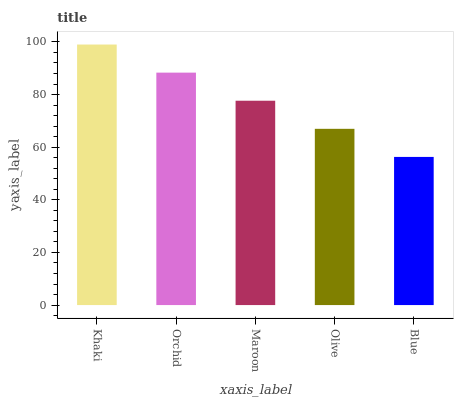Is Blue the minimum?
Answer yes or no. Yes. Is Khaki the maximum?
Answer yes or no. Yes. Is Orchid the minimum?
Answer yes or no. No. Is Orchid the maximum?
Answer yes or no. No. Is Khaki greater than Orchid?
Answer yes or no. Yes. Is Orchid less than Khaki?
Answer yes or no. Yes. Is Orchid greater than Khaki?
Answer yes or no. No. Is Khaki less than Orchid?
Answer yes or no. No. Is Maroon the high median?
Answer yes or no. Yes. Is Maroon the low median?
Answer yes or no. Yes. Is Olive the high median?
Answer yes or no. No. Is Olive the low median?
Answer yes or no. No. 